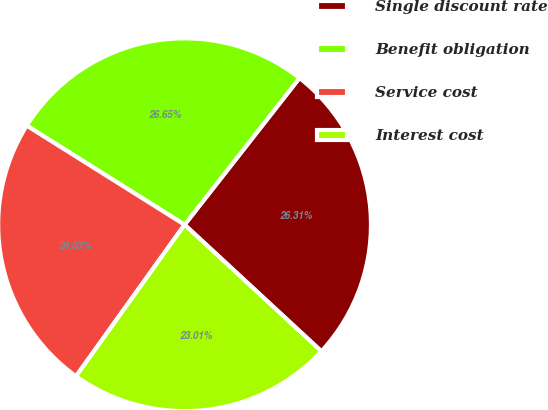<chart> <loc_0><loc_0><loc_500><loc_500><pie_chart><fcel>Single discount rate<fcel>Benefit obligation<fcel>Service cost<fcel>Interest cost<nl><fcel>26.31%<fcel>26.65%<fcel>24.03%<fcel>23.01%<nl></chart> 